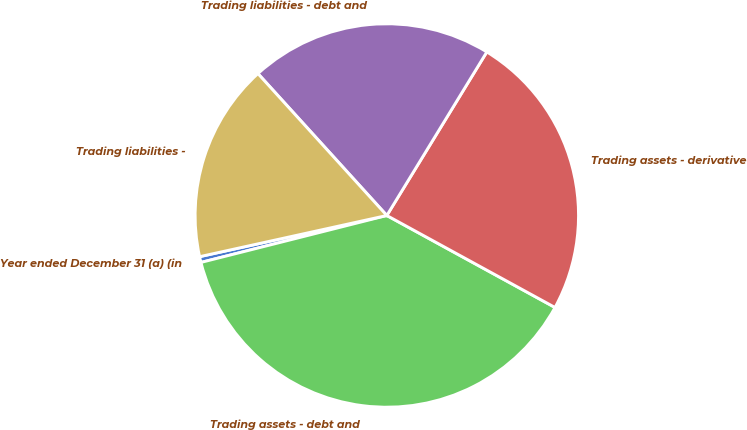Convert chart to OTSL. <chart><loc_0><loc_0><loc_500><loc_500><pie_chart><fcel>Year ended December 31 (a) (in<fcel>Trading assets - debt and<fcel>Trading assets - derivative<fcel>Trading liabilities - debt and<fcel>Trading liabilities -<nl><fcel>0.49%<fcel>38.1%<fcel>24.23%<fcel>20.47%<fcel>16.71%<nl></chart> 